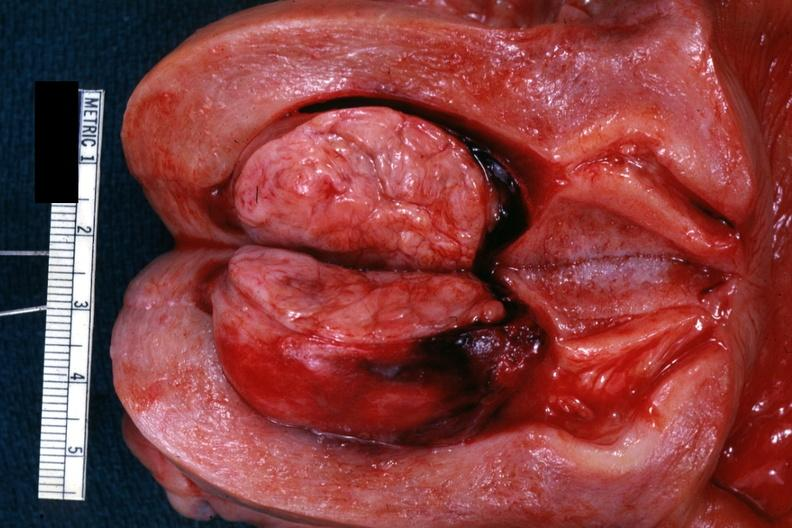s female reproductive present?
Answer the question using a single word or phrase. Yes 